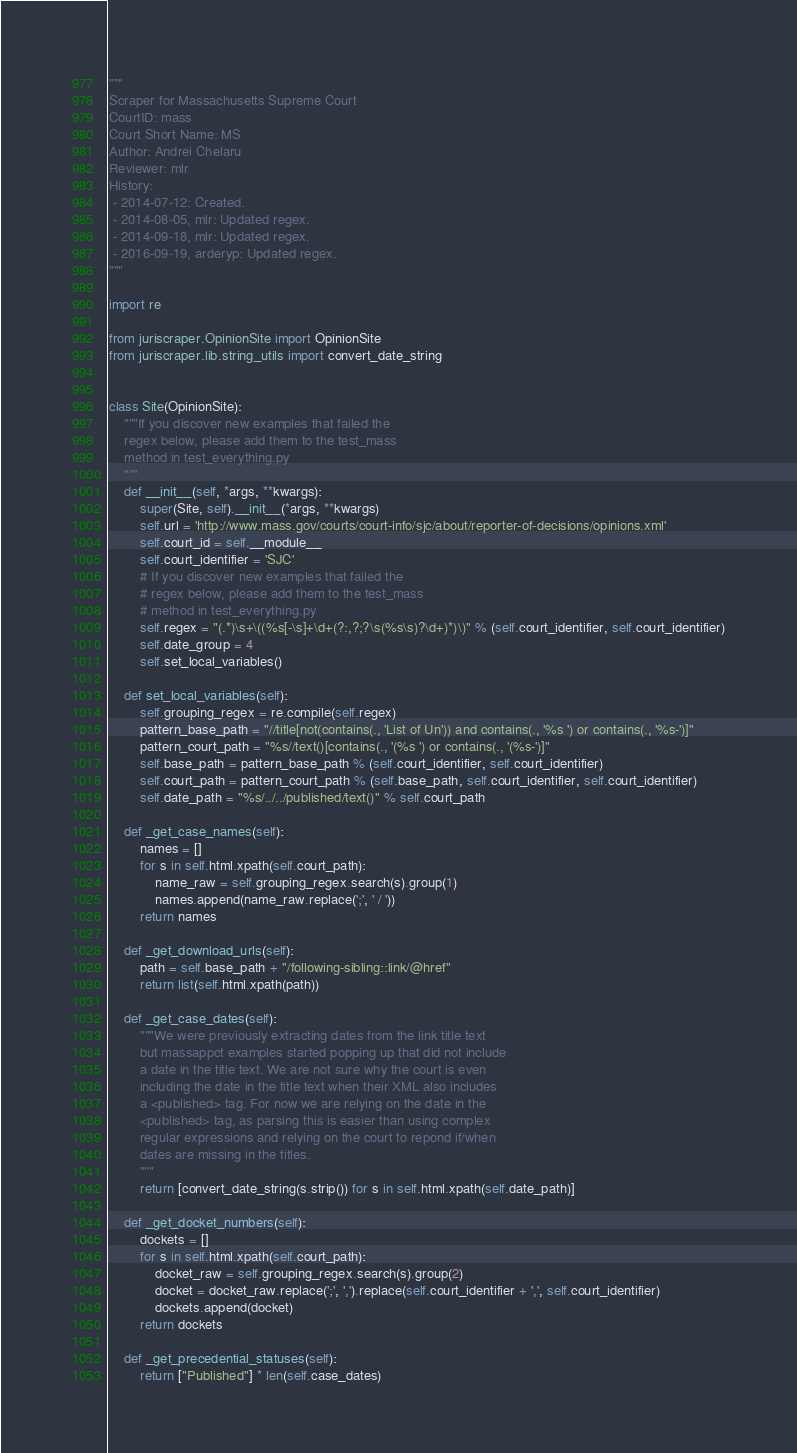Convert code to text. <code><loc_0><loc_0><loc_500><loc_500><_Python_>"""
Scraper for Massachusetts Supreme Court
CourtID: mass
Court Short Name: MS
Author: Andrei Chelaru
Reviewer: mlr
History:
 - 2014-07-12: Created.
 - 2014-08-05, mlr: Updated regex.
 - 2014-09-18, mlr: Updated regex.
 - 2016-09-19, arderyp: Updated regex.
"""

import re

from juriscraper.OpinionSite import OpinionSite
from juriscraper.lib.string_utils import convert_date_string


class Site(OpinionSite):
    """If you discover new examples that failed the
    regex below, please add them to the test_mass
    method in test_everything.py
    """
    def __init__(self, *args, **kwargs):
        super(Site, self).__init__(*args, **kwargs)
        self.url = 'http://www.mass.gov/courts/court-info/sjc/about/reporter-of-decisions/opinions.xml'
        self.court_id = self.__module__
        self.court_identifier = 'SJC'
        # If you discover new examples that failed the
        # regex below, please add them to the test_mass
        # method in test_everything.py
        self.regex = "(.*)\s+\((%s[-\s]+\d+(?:,?;?\s(%s\s)?\d+)*)\)" % (self.court_identifier, self.court_identifier)
        self.date_group = 4
        self.set_local_variables()

    def set_local_variables(self):
        self.grouping_regex = re.compile(self.regex)
        pattern_base_path = "//title[not(contains(., 'List of Un')) and contains(., '%s ') or contains(., '%s-')]"
        pattern_court_path = "%s//text()[contains(., '(%s ') or contains(., '(%s-')]"
        self.base_path = pattern_base_path % (self.court_identifier, self.court_identifier)
        self.court_path = pattern_court_path % (self.base_path, self.court_identifier, self.court_identifier)
        self.date_path = "%s/../../published/text()" % self.court_path

    def _get_case_names(self):
        names = []
        for s in self.html.xpath(self.court_path):
            name_raw = self.grouping_regex.search(s).group(1)
            names.append(name_raw.replace(';', ' / '))
        return names

    def _get_download_urls(self):
        path = self.base_path + "/following-sibling::link/@href"
        return list(self.html.xpath(path))

    def _get_case_dates(self):
        """We were previously extracting dates from the link title text
        but massappct examples started popping up that did not include
        a date in the title text. We are not sure why the court is even
        including the date in the title text when their XML also includes
        a <published> tag. For now we are relying on the date in the
        <published> tag, as parsing this is easier than using complex
        regular expressions and relying on the court to repond if/when
        dates are missing in the titles.
        """
        return [convert_date_string(s.strip()) for s in self.html.xpath(self.date_path)]

    def _get_docket_numbers(self):
        dockets = []
        for s in self.html.xpath(self.court_path):
            docket_raw = self.grouping_regex.search(s).group(2)
            docket = docket_raw.replace(';', ',').replace(self.court_identifier + ',', self.court_identifier)
            dockets.append(docket)
        return dockets

    def _get_precedential_statuses(self):
        return ["Published"] * len(self.case_dates)
</code> 